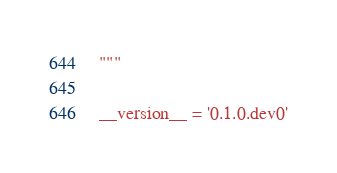Convert code to text. <code><loc_0><loc_0><loc_500><loc_500><_Python_>"""

__version__ = '0.1.0.dev0'
</code> 